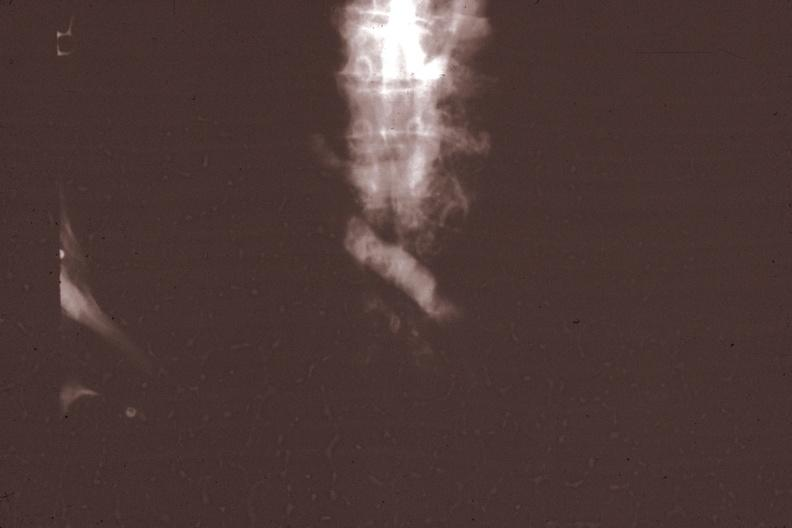what corresponds?
Answer the question using a single word or phrase. Gross photo of tumor in this file 